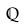<formula> <loc_0><loc_0><loc_500><loc_500>\mathbb { Q }</formula> 